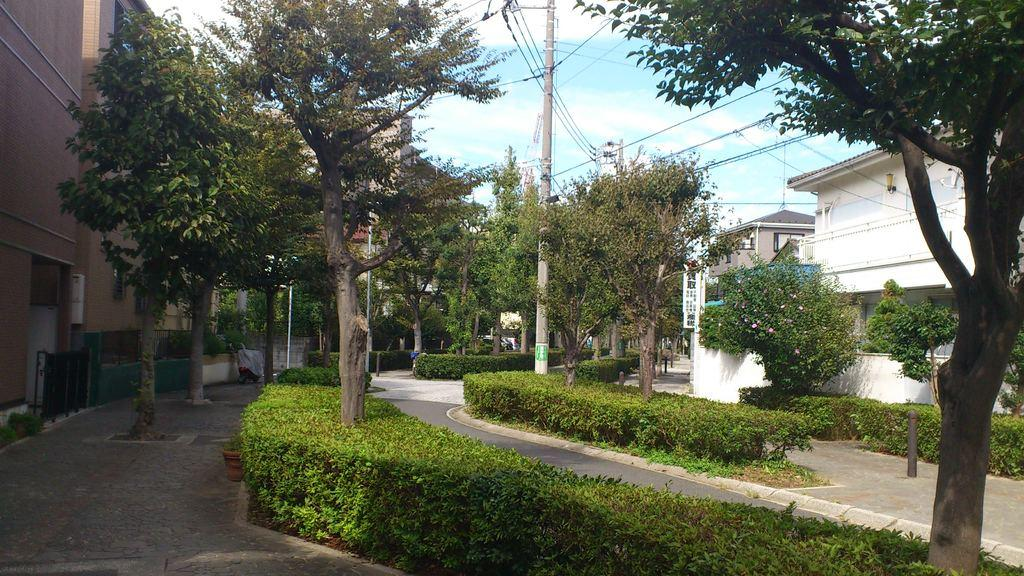What type of structures can be seen on both sides of the image? There are houses on both the left and right sides of the image. What type of vegetation is present on both sides of the image? Trees are present on both the left and right sides of the image. What else can be seen in the image besides houses and trees? Plants, poles, a board, and bushes are visible in the image. What is the condition of the sky in the image? The sky is cloudy in the image. What type of ornament is hanging from the board in the image? There is no ornament hanging from the board in the image; only a board is visible. What substance is being used to maintain the plants in the image? The provided facts do not mention any substance being used to maintain the plants in the image. 